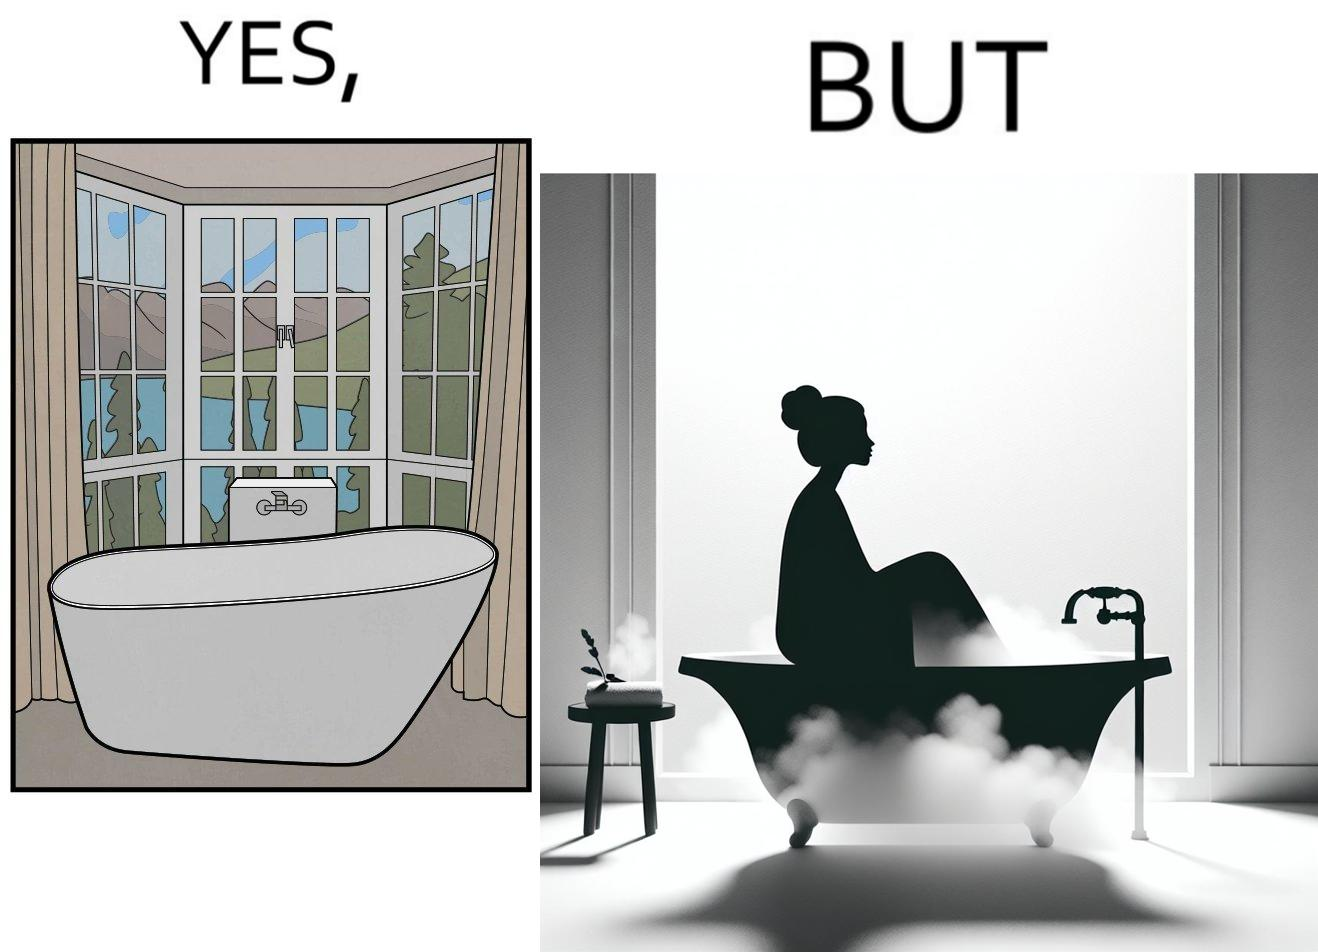What makes this image funny or satirical? The image is ironical, as a bathtub near a window having a very scenic view, becomes misty when someone is bathing, thus making the scenic view blurry. 